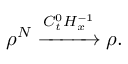<formula> <loc_0><loc_0><loc_500><loc_500>\rho ^ { N } \xrightarrow [ ] { C _ { t } ^ { 0 } H _ { x } ^ { - 1 } } \rho .</formula> 